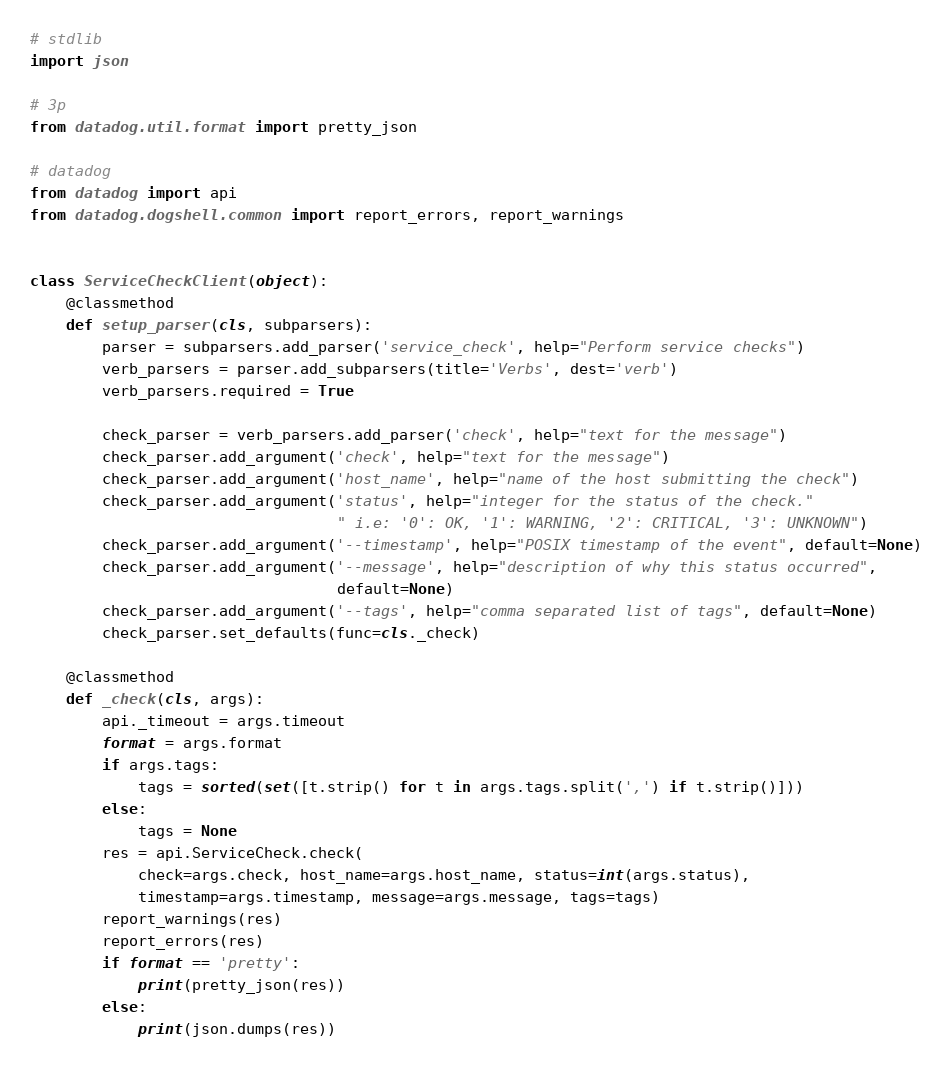Convert code to text. <code><loc_0><loc_0><loc_500><loc_500><_Python_># stdlib
import json

# 3p
from datadog.util.format import pretty_json

# datadog
from datadog import api
from datadog.dogshell.common import report_errors, report_warnings


class ServiceCheckClient(object):
    @classmethod
    def setup_parser(cls, subparsers):
        parser = subparsers.add_parser('service_check', help="Perform service checks")
        verb_parsers = parser.add_subparsers(title='Verbs', dest='verb')
        verb_parsers.required = True

        check_parser = verb_parsers.add_parser('check', help="text for the message")
        check_parser.add_argument('check', help="text for the message")
        check_parser.add_argument('host_name', help="name of the host submitting the check")
        check_parser.add_argument('status', help="integer for the status of the check."
                                  " i.e: '0': OK, '1': WARNING, '2': CRITICAL, '3': UNKNOWN")
        check_parser.add_argument('--timestamp', help="POSIX timestamp of the event", default=None)
        check_parser.add_argument('--message', help="description of why this status occurred",
                                  default=None)
        check_parser.add_argument('--tags', help="comma separated list of tags", default=None)
        check_parser.set_defaults(func=cls._check)

    @classmethod
    def _check(cls, args):
        api._timeout = args.timeout
        format = args.format
        if args.tags:
            tags = sorted(set([t.strip() for t in args.tags.split(',') if t.strip()]))
        else:
            tags = None
        res = api.ServiceCheck.check(
            check=args.check, host_name=args.host_name, status=int(args.status),
            timestamp=args.timestamp, message=args.message, tags=tags)
        report_warnings(res)
        report_errors(res)
        if format == 'pretty':
            print(pretty_json(res))
        else:
            print(json.dumps(res))
</code> 